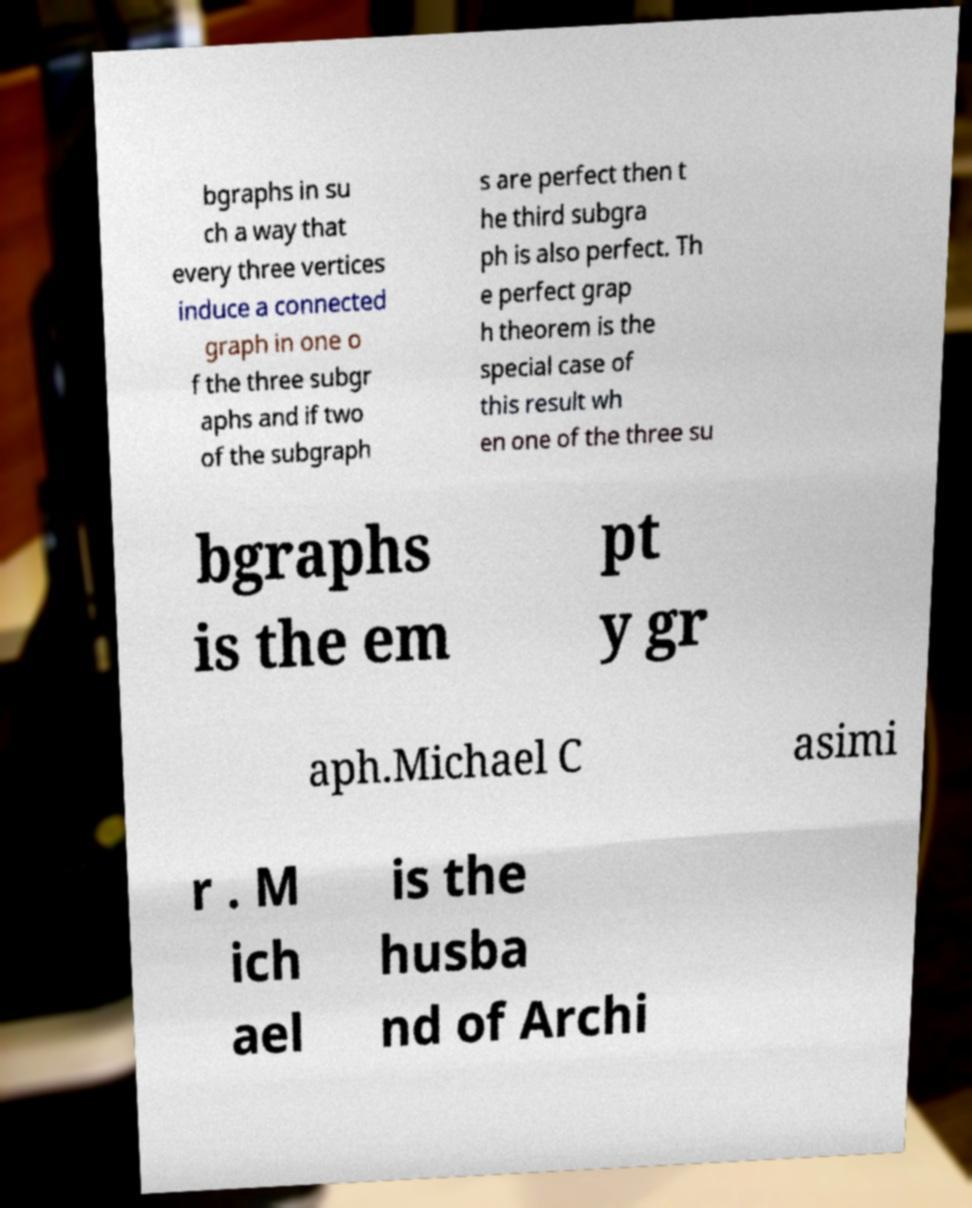Please identify and transcribe the text found in this image. bgraphs in su ch a way that every three vertices induce a connected graph in one o f the three subgr aphs and if two of the subgraph s are perfect then t he third subgra ph is also perfect. Th e perfect grap h theorem is the special case of this result wh en one of the three su bgraphs is the em pt y gr aph.Michael C asimi r . M ich ael is the husba nd of Archi 